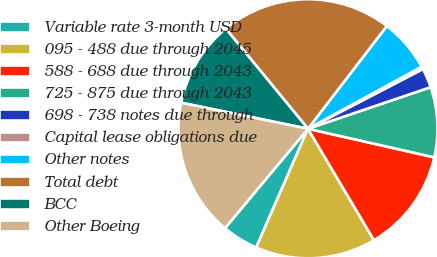<chart> <loc_0><loc_0><loc_500><loc_500><pie_chart><fcel>Variable rate 3-month USD<fcel>095 - 488 due through 2045<fcel>588 - 688 due through 2043<fcel>725 - 875 due through 2043<fcel>698 - 738 notes due through<fcel>Capital lease obligations due<fcel>Other notes<fcel>Total debt<fcel>BCC<fcel>Other Boeing<nl><fcel>4.53%<fcel>15.05%<fcel>12.95%<fcel>8.74%<fcel>2.43%<fcel>0.32%<fcel>6.63%<fcel>21.36%<fcel>10.84%<fcel>17.15%<nl></chart> 